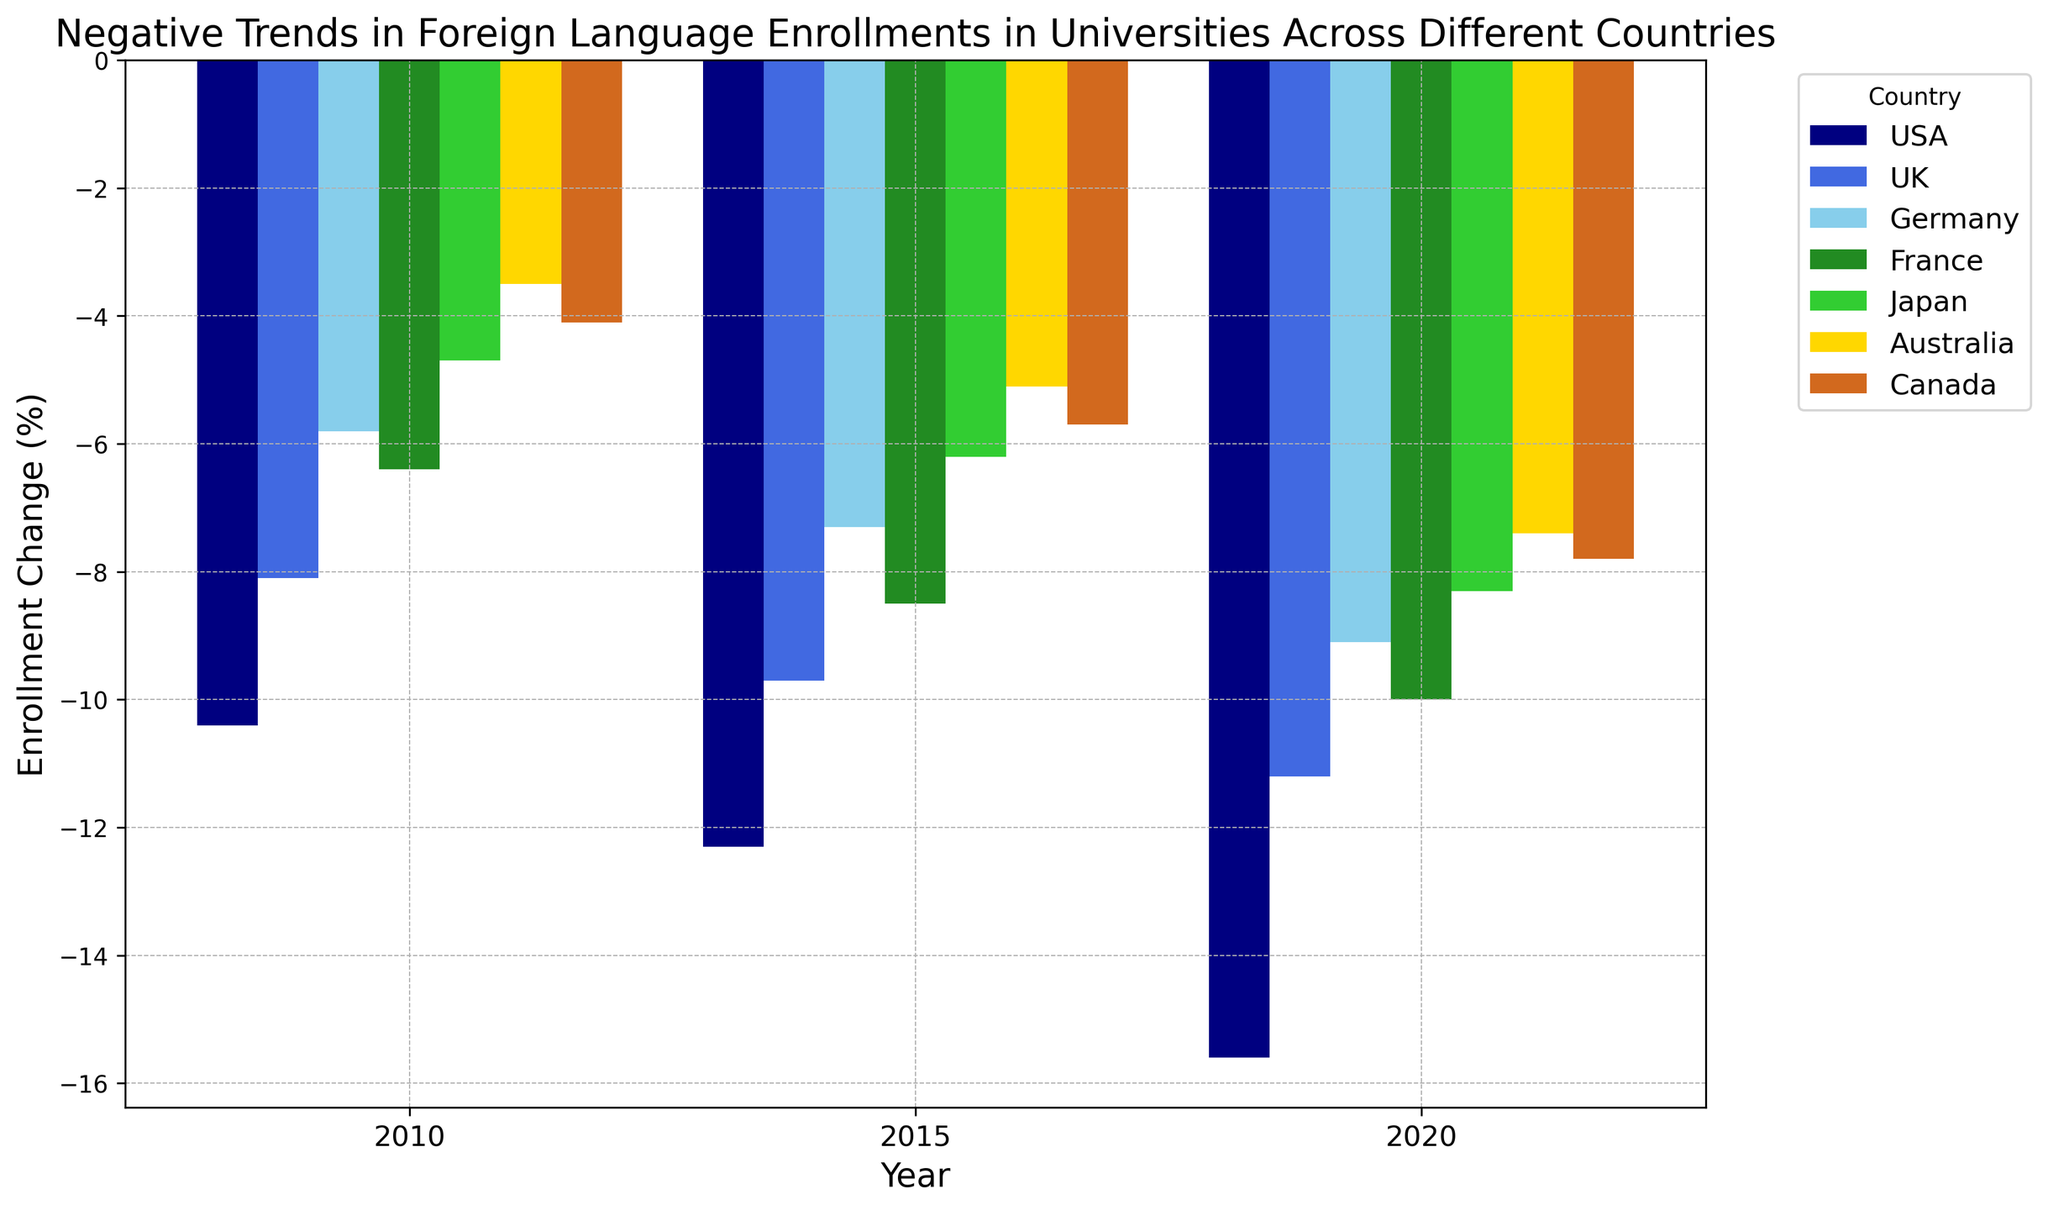Which country had the smallest decrease in foreign language enrollments in 2010? Look at the bars corresponding to the year 2010 and compare their heights. The bar representing Australia is the smallest in height, indicating the smallest decrease.
Answer: Australia Compare the foreign language enrollment decreases in the USA and UK in 2020. Which one is greater? For the year 2020, compare the height of the bars for the USA and the UK. The bar for the USA is lower, indicating a greater decrease.
Answer: USA What is the average percentage change in enrollment in Germany across all three years? Sum the enrollment changes for Germany (-5.8, -7.3, -9.1) and divide by 3: (-5.8 - 7.3 - 9.1)/3 = -22.2/3 = -7.4.
Answer: -7.4 Which country exhibited the most significant increase in the steepness of the trend from 2010 to 2020? Calculate the difference between the 2010 and 2020 enrollments for each country: USA (-15.6 - (-10.4) = -5.2), UK (-11.2 - (-8.1) = -3.1), Germany (-9.1 - (-5.8) = -3.3), France (-10.0 - (-6.4) = -3.6), Japan (-8.3 - (-4.7) = -3.6), Australia (-7.4 - (-3.5) = -3.9), Canada (-7.8 - (-4.1) = -3.7). The USA has the highest absolute change of -5.2.
Answer: USA Between 2015 and 2020, which country showed the least amount of change in enrollment rates? Look at the differences between 2015 and 2020 values for each country: USA (-15.6 - (-12.3) = -3.3), UK (-11.2 - (-9.7) = -1.5), Germany (-9.1 - (-7.3) = -1.8), France (-10.0 - (-8.5) = -1.5), Japan (-8.3 - (-6.2) = -2.1), Australia (-7.4 - (-5.1) = -2.3), Canada (-7.8 - (-5.7) = -2.1). The UK and France had the smallest change of -1.5.
Answer: UK & France Which country's bar for 2015 is closest in height to Japan's bar for 2020? Visually compare the relative heights of the bars. Japan's 2020 bar (-8.3) is close in height to Canada's 2015 bar (-5.7).
Answer: Japan (2020) & Canada (2015) What is the total enrollment change percentage for all countries in 2010? Sum the enrollment changes for all countries in 2010: (-10.4) + (-8.1) + (-5.8) + (-6.4) + (-4.7) + (-3.5) + (-4.1) = -43.0.
Answer: -43.0 Is there a country that consistently exhibited a decline in foreign language enrollments across all three years? Check if every country’s enrollment change is negative for 2010, 2015, and 2020. All countries show a continuous decline since all values are negative.
Answer: Yes 